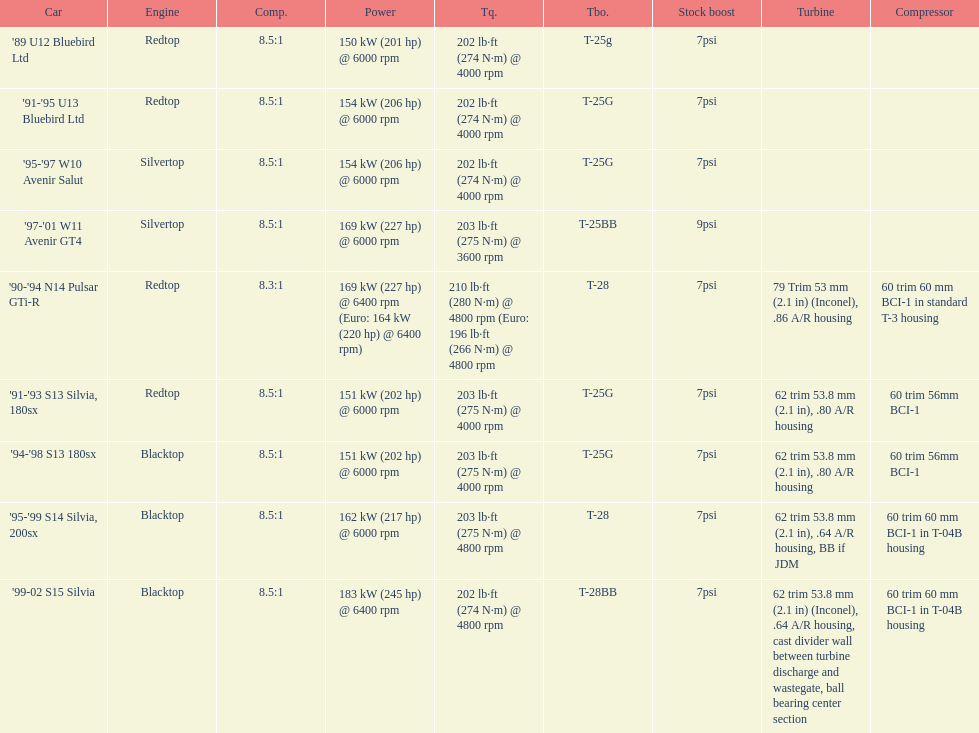How many models used the redtop engine? 4. 